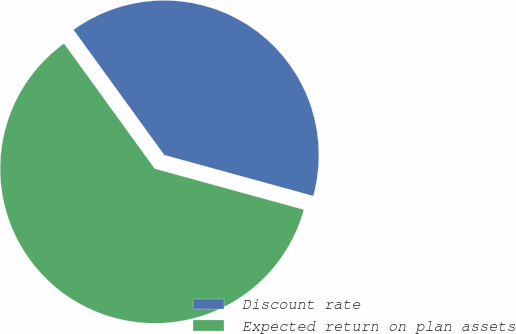Convert chart to OTSL. <chart><loc_0><loc_0><loc_500><loc_500><pie_chart><fcel>Discount rate<fcel>Expected return on plan assets<nl><fcel>39.25%<fcel>60.75%<nl></chart> 